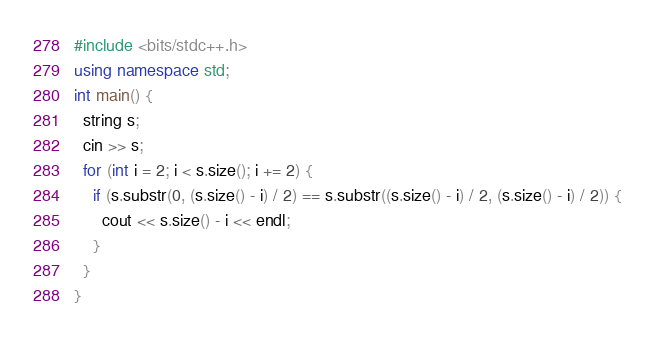Convert code to text. <code><loc_0><loc_0><loc_500><loc_500><_C++_>#include <bits/stdc++.h>
using namespace std;
int main() {
  string s;
  cin >> s;
  for (int i = 2; i < s.size(); i += 2) {
    if (s.substr(0, (s.size() - i) / 2) == s.substr((s.size() - i) / 2, (s.size() - i) / 2)) {
      cout << s.size() - i << endl;
    }
  }
}</code> 